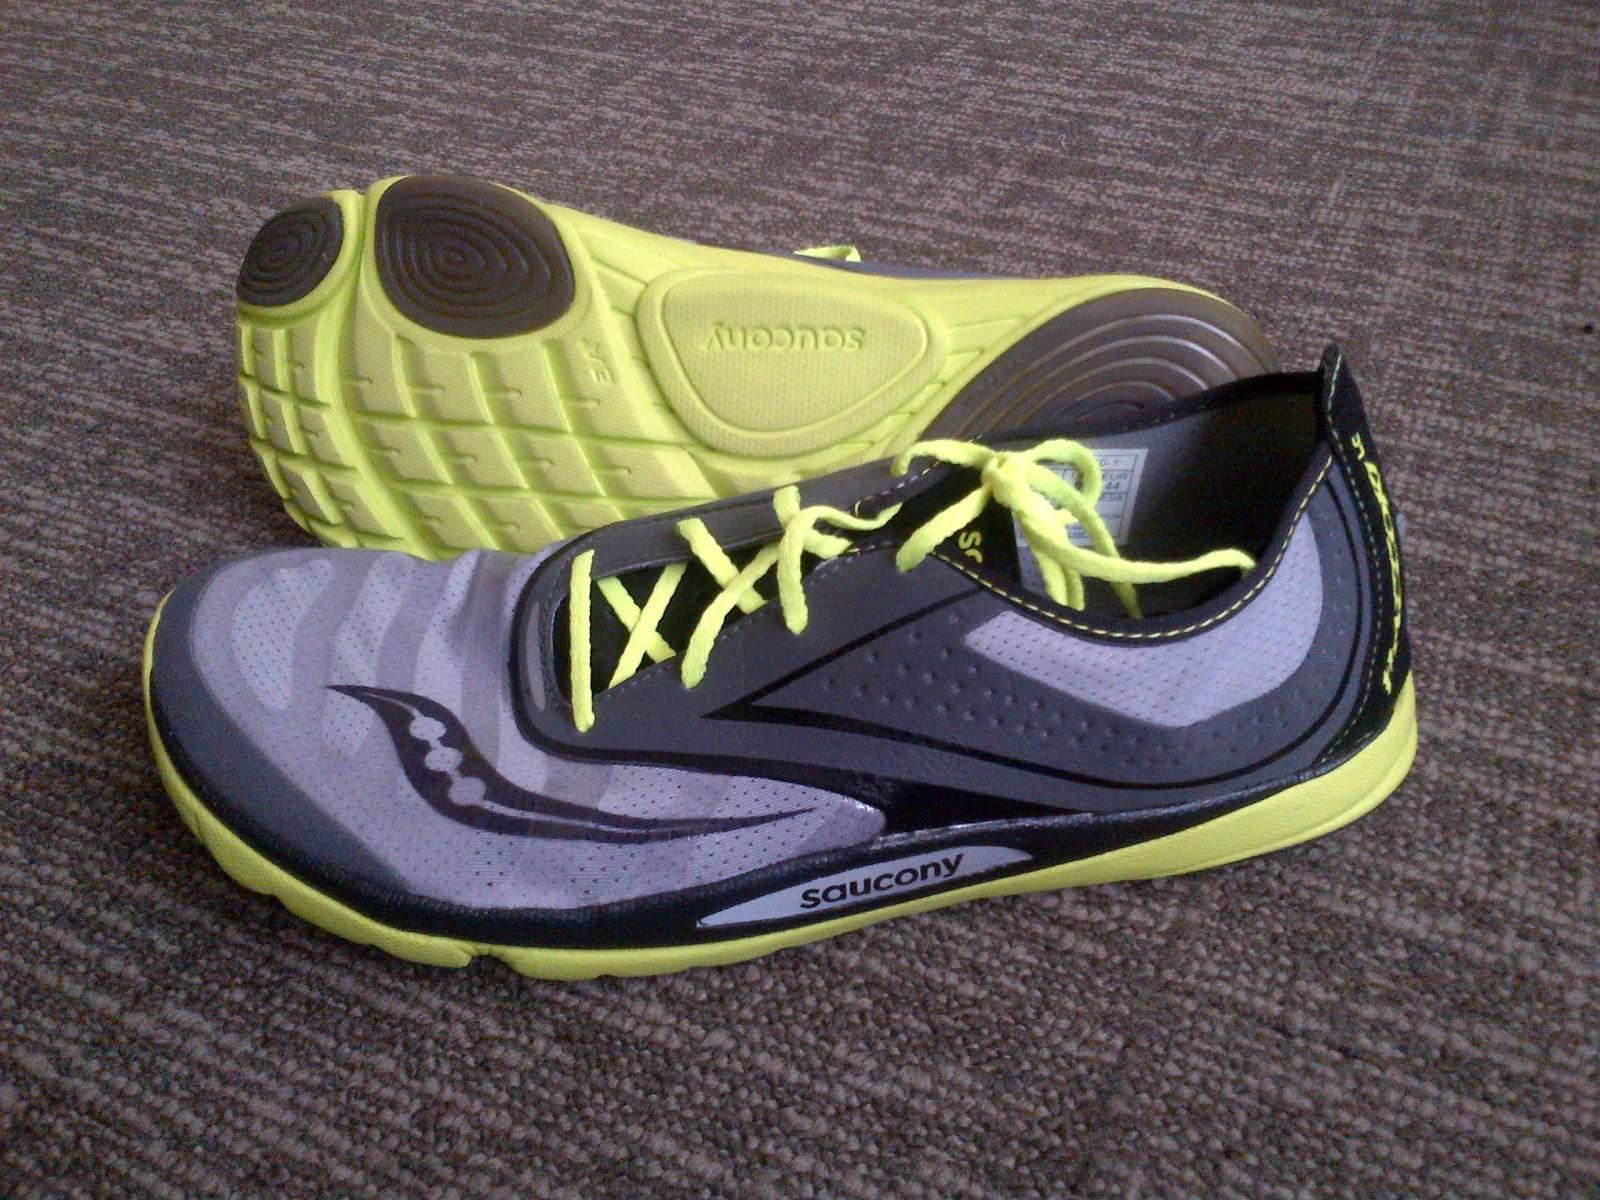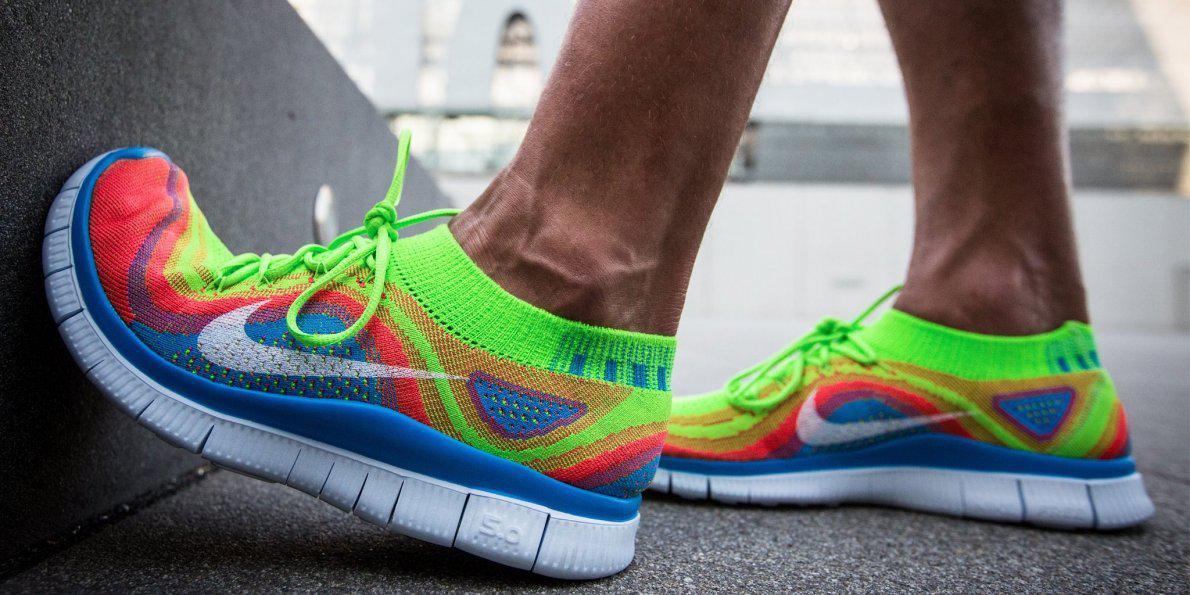The first image is the image on the left, the second image is the image on the right. Assess this claim about the two images: "One image shows a pair of feet in sneakers, and the other shows a pair of unworn shoes, one turned so its sole faces the camera.". Correct or not? Answer yes or no. Yes. The first image is the image on the left, the second image is the image on the right. Evaluate the accuracy of this statement regarding the images: "The left hand image shows both the top and the bottom of the pair of shoes that are not on a person, while the right hand image shows shoes being worn by a human.". Is it true? Answer yes or no. Yes. 